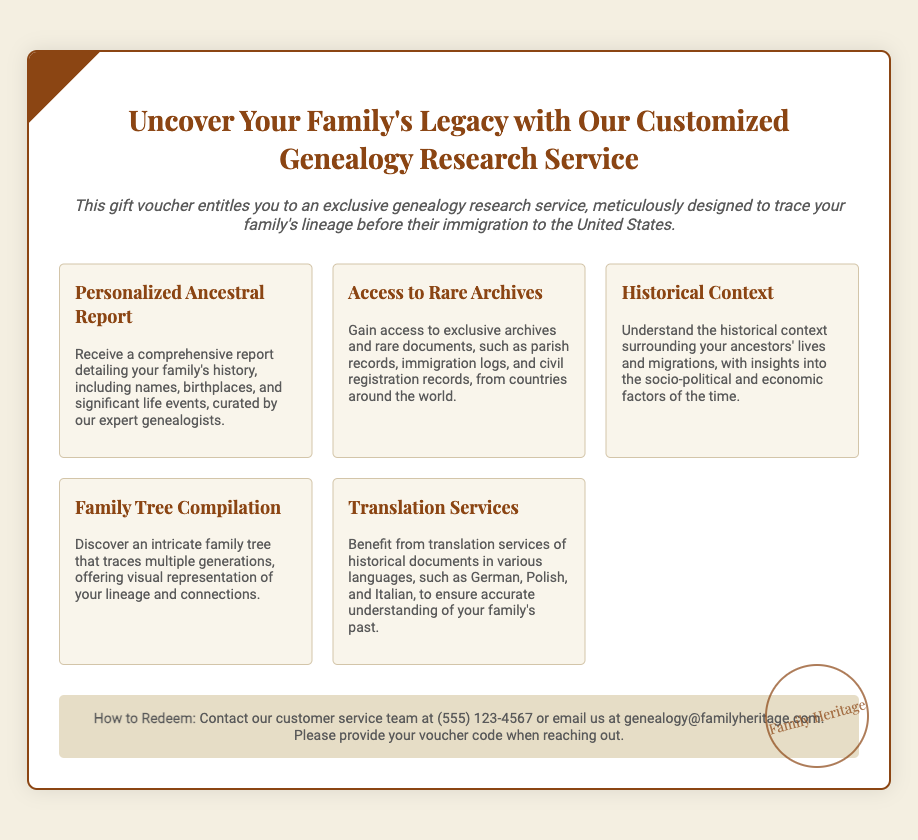What is the title of the service? The title of the service is stated prominently at the top of the voucher.
Answer: Uncover Your Family's Legacy with Our Customized Genealogy Research Service What kind of report is included in the services? The document specifically mentions a type of report that will be provided to the recipients of the voucher.
Answer: Personalized Ancestral Report How can one redeem the voucher? The document outlines the procedure for redeeming the voucher, including contact options.
Answer: Contact our customer service team at (555) 123-4567 or email us at genealogy@familyheritage.com What is one type of document access provided? The document lists several exclusive resources that recipients can access.
Answer: Rare Archives What historical context is provided in the services? The document mentions that understanding the background of ancestors is part of the service.
Answer: Historical Context How many services are listed in the voucher? The document lists a specific number of distinct services offered.
Answer: Five What type of family representation will be created? The document describes a specific form of family representation within the services.
Answer: Family Tree Compilation What type of translation services are mentioned? The document specifies types of translation services provided for historical documents.
Answer: Various languages, such as German, Polish, and Italian What color is the background of the voucher? The document describes the background color of the voucher design.
Answer: #f4efe1 